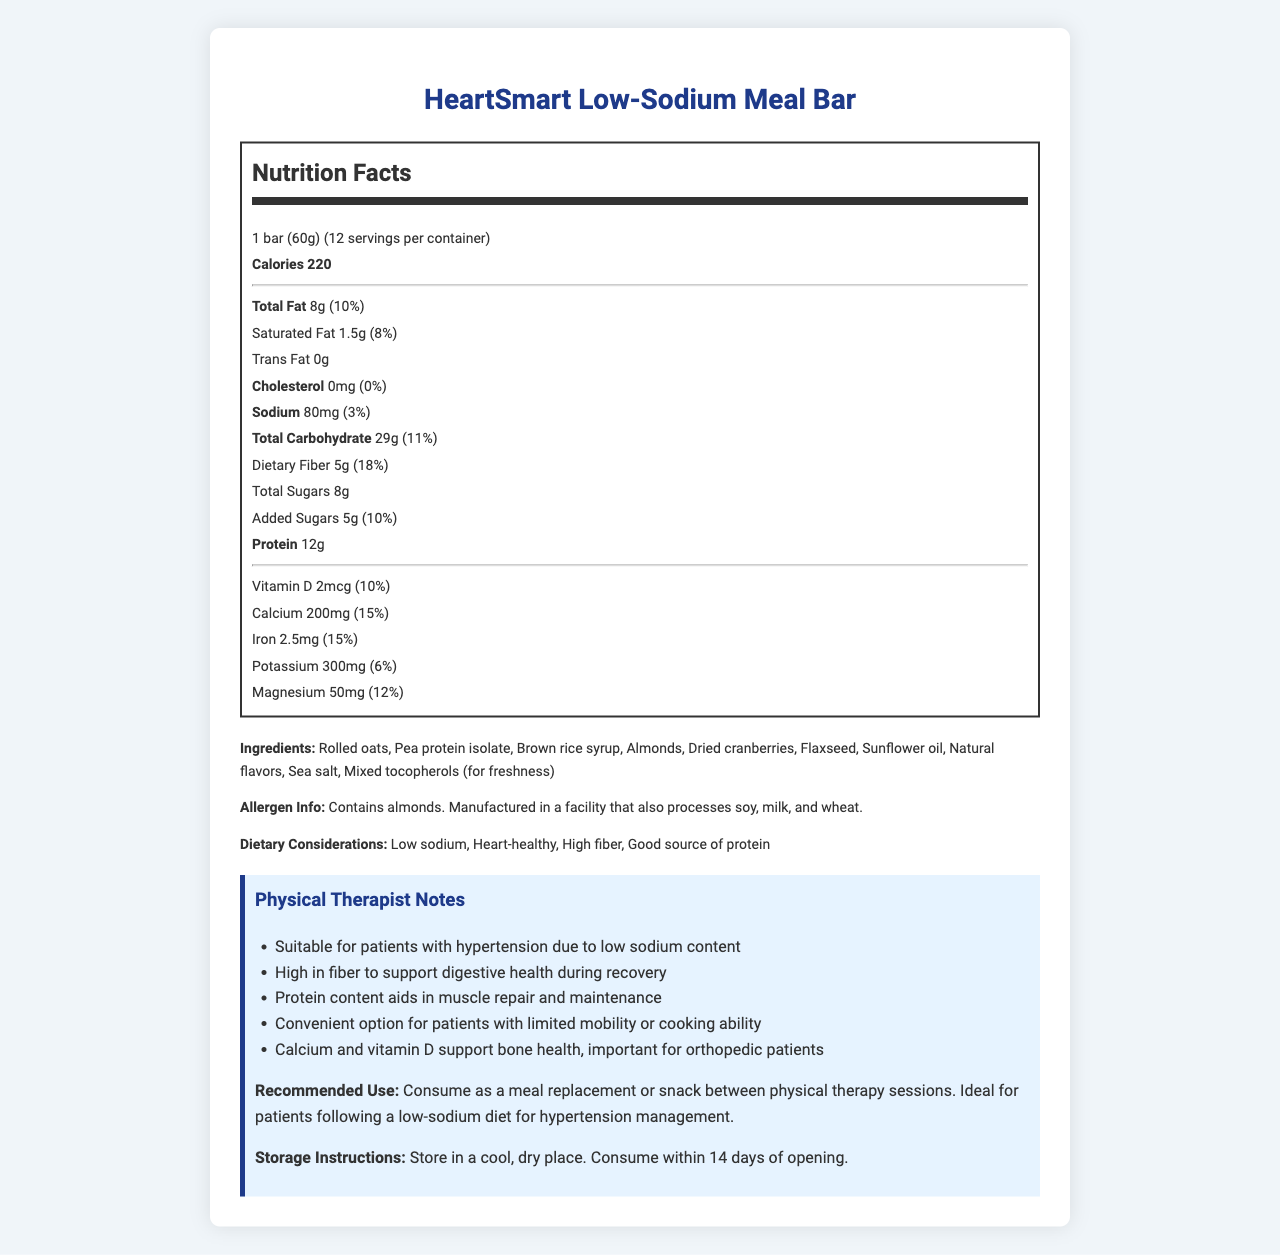what is the serving size of the HeartSmart Low-Sodium Meal Bar? The serving size is listed under the Nutrition Facts section, specifying "1 bar (60g)".
Answer: 1 bar (60g) how many calories are there per serving? The calories per serving are explicitly mentioned as 220 in the Nutrition Facts section.
Answer: 220 calories what is the total amount of fat in one serving of the bar? The total amount of fat is listed as 8g in the Nutrition Facts section.
Answer: 8g what percentage of the daily value does the sodium content represent? The sodium content is 80mg, which is indicated to be 3% of the daily value.
Answer: 3% how much protein does one bar contain? The protein content per serving is listed as 12g in the Nutrition Facts section.
Answer: 12g which of the following ingredients is used in the bar? A. Rolled oats B. Corn syrup C. Peanuts D. Eggs The ingredients list includes "Rolled oats" but not "Corn syrup," "Peanuts," or "Eggs."
Answer: A. Rolled oats how much dietary fiber is in each serving? The dietary fiber content is listed as 5g per serving in the Nutrition Facts section.
Answer: 5g what vitamins and minerals does the bar provide? (Select all that apply) i. Vitamin D ii. Calcium iii. Iron iv. Potassium v. Magnesium The bar provides Vitamin D, Calcium, Iron, Potassium, and Magnesium as listed in their respective sections under Nutrition Facts.
Answer: i, ii, iii, iv, v are there any allergens in the HeartSmart Low-Sodium Meal Bar? Yes, the bar contains almonds, and the allergen information mentions that it is manufactured in a facility that processes soy, milk, and wheat.
Answer: Yes Is this product suitable for patients with hypertension? Yes, the low-sodium content and specific physical therapist notes indicate that it is suitable for patients with hypertension.
Answer: Yes describe the main points of the document. The detailed nutritional values, ingredients, and additional notes highlight the bar's health benefits and intended use for specific dietary conditions.
Answer: The document provides detailed nutritional information for the HeartSmart Low-Sodium Meal Bar, emphasizing its suitability for patients with hypertension due to its low sodium content. It lists essential nutritional values, ingredients, allergen information, dietary considerations, physical therapist notes, recommended use, and storage instructions. what is the shelf life of the HeartSmart Low-Sodium Meal Bar after opening? The document specifies that the bar should be consumed within 14 days of opening, but it does not provide information on the exact shelf life.
Answer: Not enough information how much calcium is found in one serving of the bar? The amount of calcium per serving is 200mg as listed in the Nutrition Facts section.
Answer: 200mg is this product a good source of protein? Yes, the bar contains 12g of protein per serving, and it is mentioned in the dietary considerations as a good source of protein.
Answer: Yes 